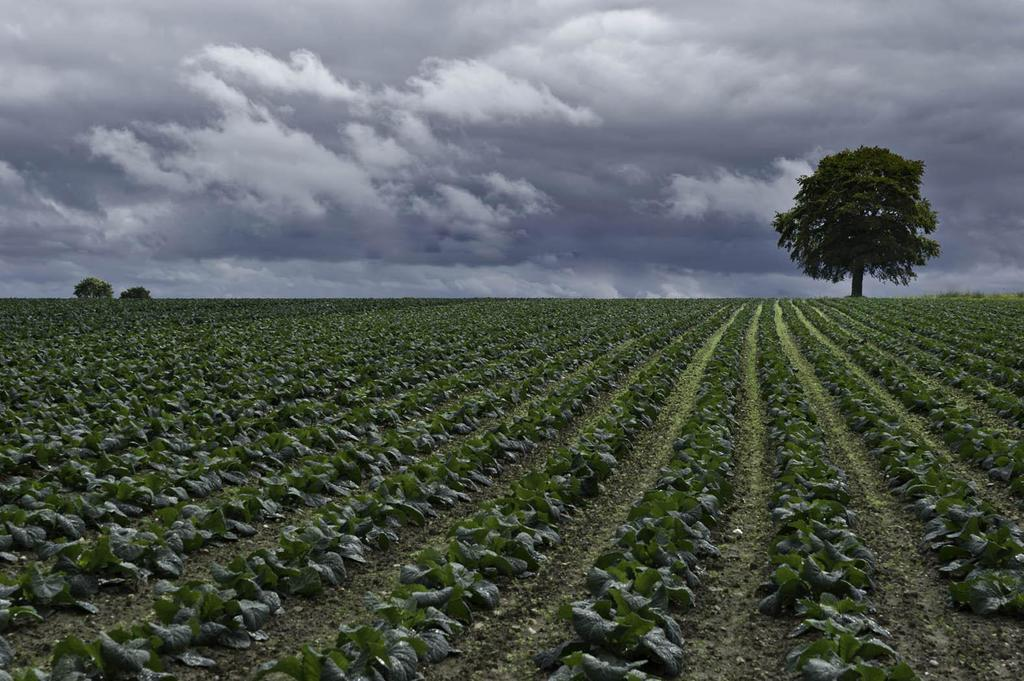What type of vegetation can be seen on the ground in the image? There are plants on the ground in the image. What can be seen in the background of the image? There are trees and the sky visible in the background of the image. How does the joke affect the plants in the image? There is no joke present in the image, so it cannot affect the plants. 